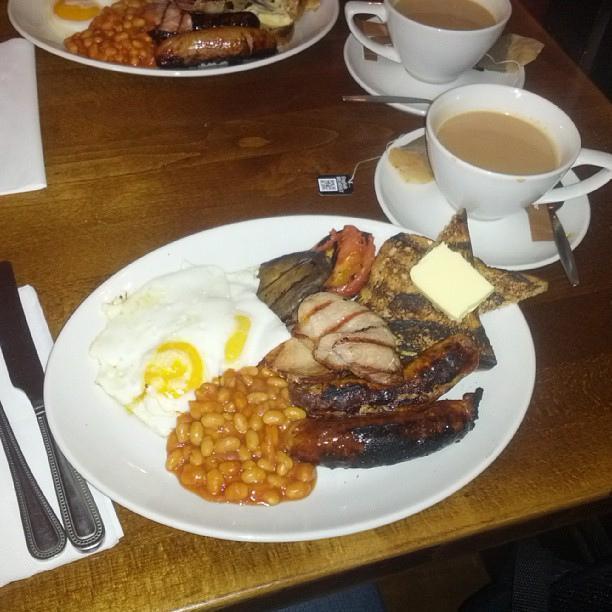What is the side dish on the plate?
Indicate the correct response by choosing from the four available options to answer the question.
Options: Fries, tomato, apples, beans. Beans. 